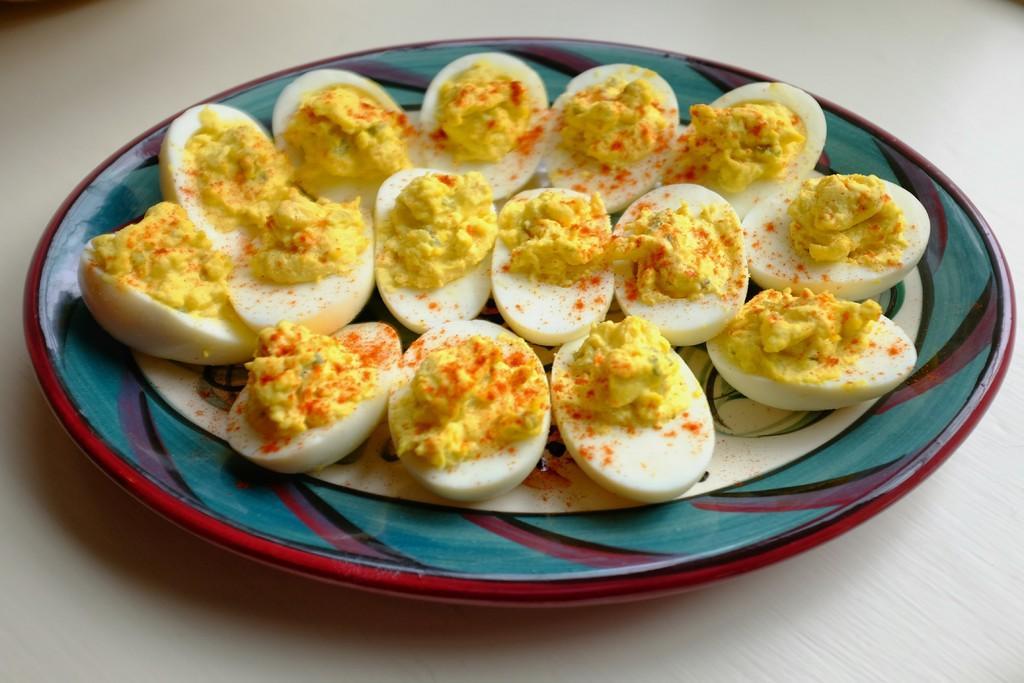In one or two sentences, can you explain what this image depicts? In the center of the image there are boiled eggs in plate placed on the table. 